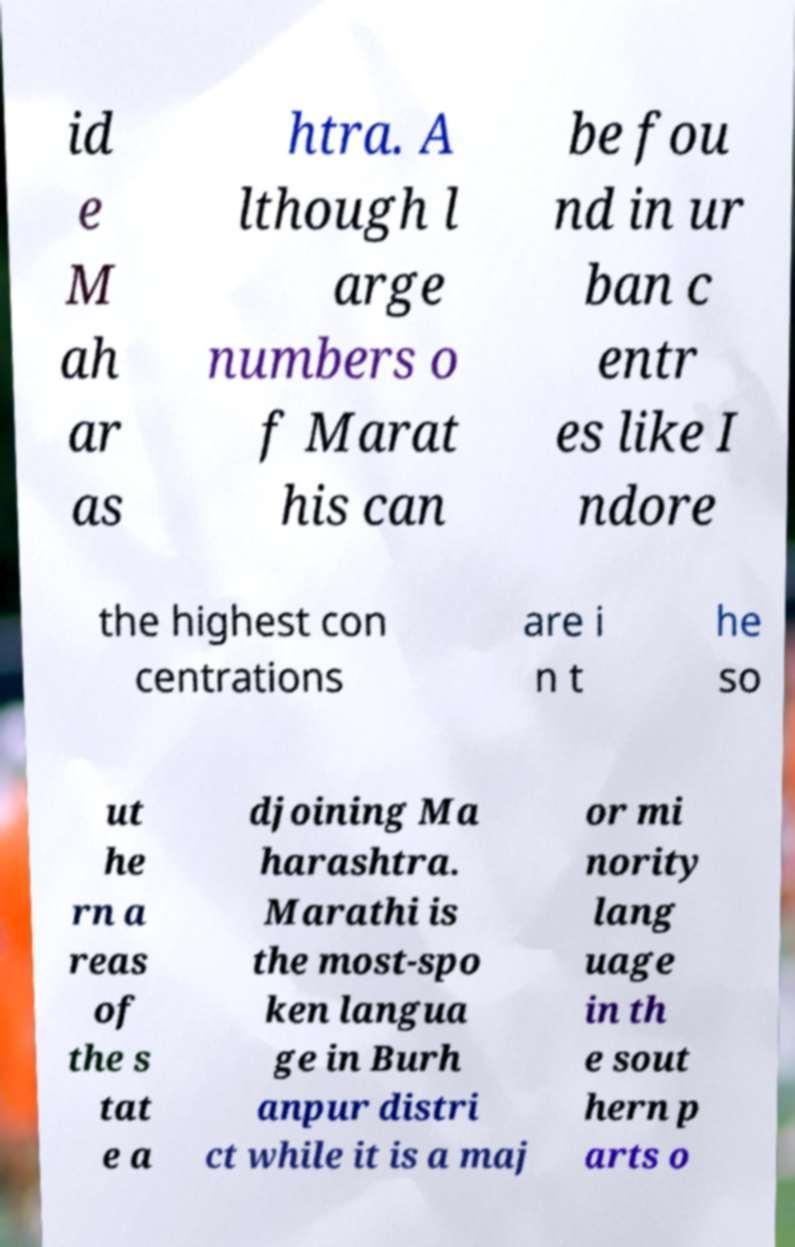Please identify and transcribe the text found in this image. id e M ah ar as htra. A lthough l arge numbers o f Marat his can be fou nd in ur ban c entr es like I ndore the highest con centrations are i n t he so ut he rn a reas of the s tat e a djoining Ma harashtra. Marathi is the most-spo ken langua ge in Burh anpur distri ct while it is a maj or mi nority lang uage in th e sout hern p arts o 